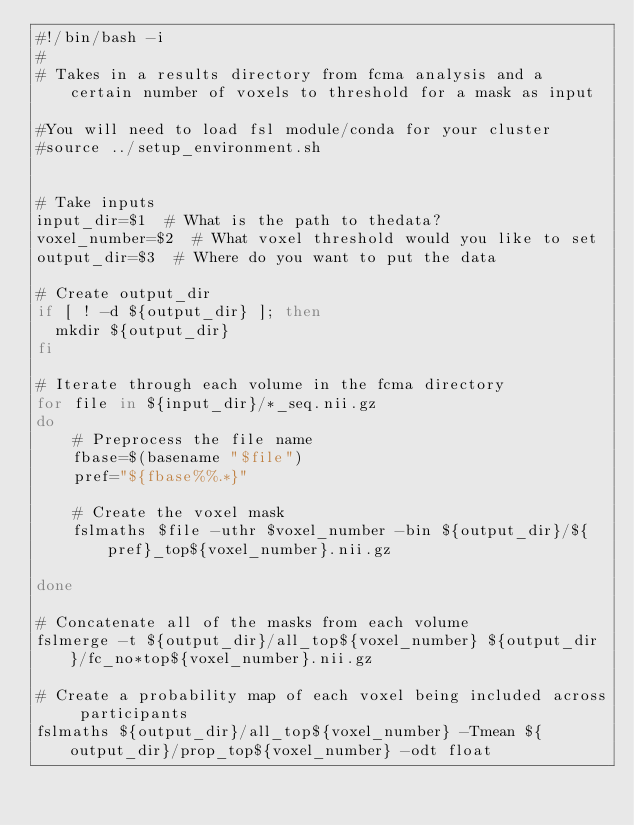<code> <loc_0><loc_0><loc_500><loc_500><_Bash_>#!/bin/bash -i
#
# Takes in a results directory from fcma analysis and a certain number of voxels to threshold for a mask as input

#You will need to load fsl module/conda for your cluster
#source ../setup_environment.sh


# Take inputs
input_dir=$1  # What is the path to thedata?
voxel_number=$2  # What voxel threshold would you like to set
output_dir=$3  # Where do you want to put the data

# Create output_dir
if [ ! -d ${output_dir} ]; then
  mkdir ${output_dir}
fi

# Iterate through each volume in the fcma directory
for file in ${input_dir}/*_seq.nii.gz
do	
	# Preprocess the file name
	fbase=$(basename "$file")
	pref="${fbase%%.*}"
	
	# Create the voxel mask
	fslmaths $file -uthr $voxel_number -bin ${output_dir}/${pref}_top${voxel_number}.nii.gz

done

# Concatenate all of the masks from each volume
fslmerge -t ${output_dir}/all_top${voxel_number} ${output_dir}/fc_no*top${voxel_number}.nii.gz

# Create a probability map of each voxel being included across participants
fslmaths ${output_dir}/all_top${voxel_number} -Tmean ${output_dir}/prop_top${voxel_number} -odt float
</code> 